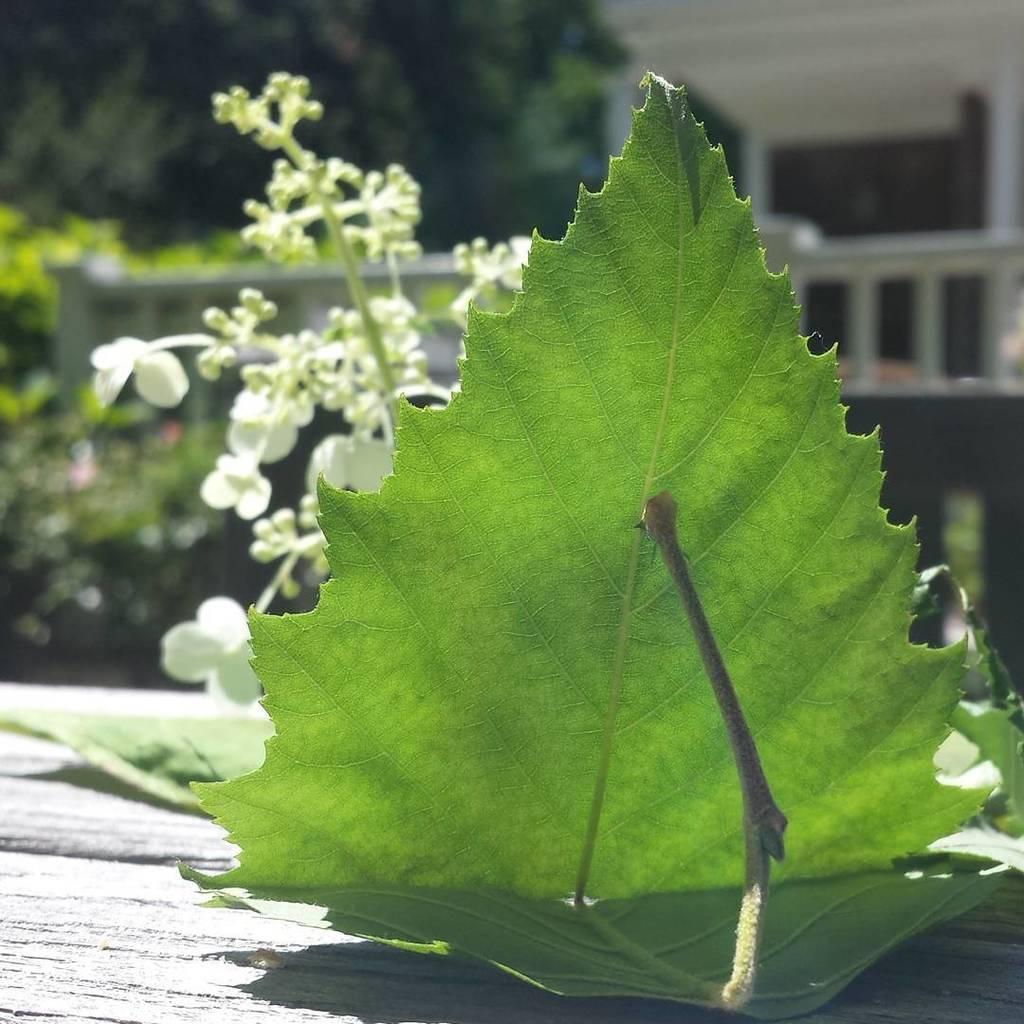Please provide a concise description of this image. In the center of the image we can see leaves and flowers, which are in white color. In the background, we can see one building, fence, trees and a few other objects. 